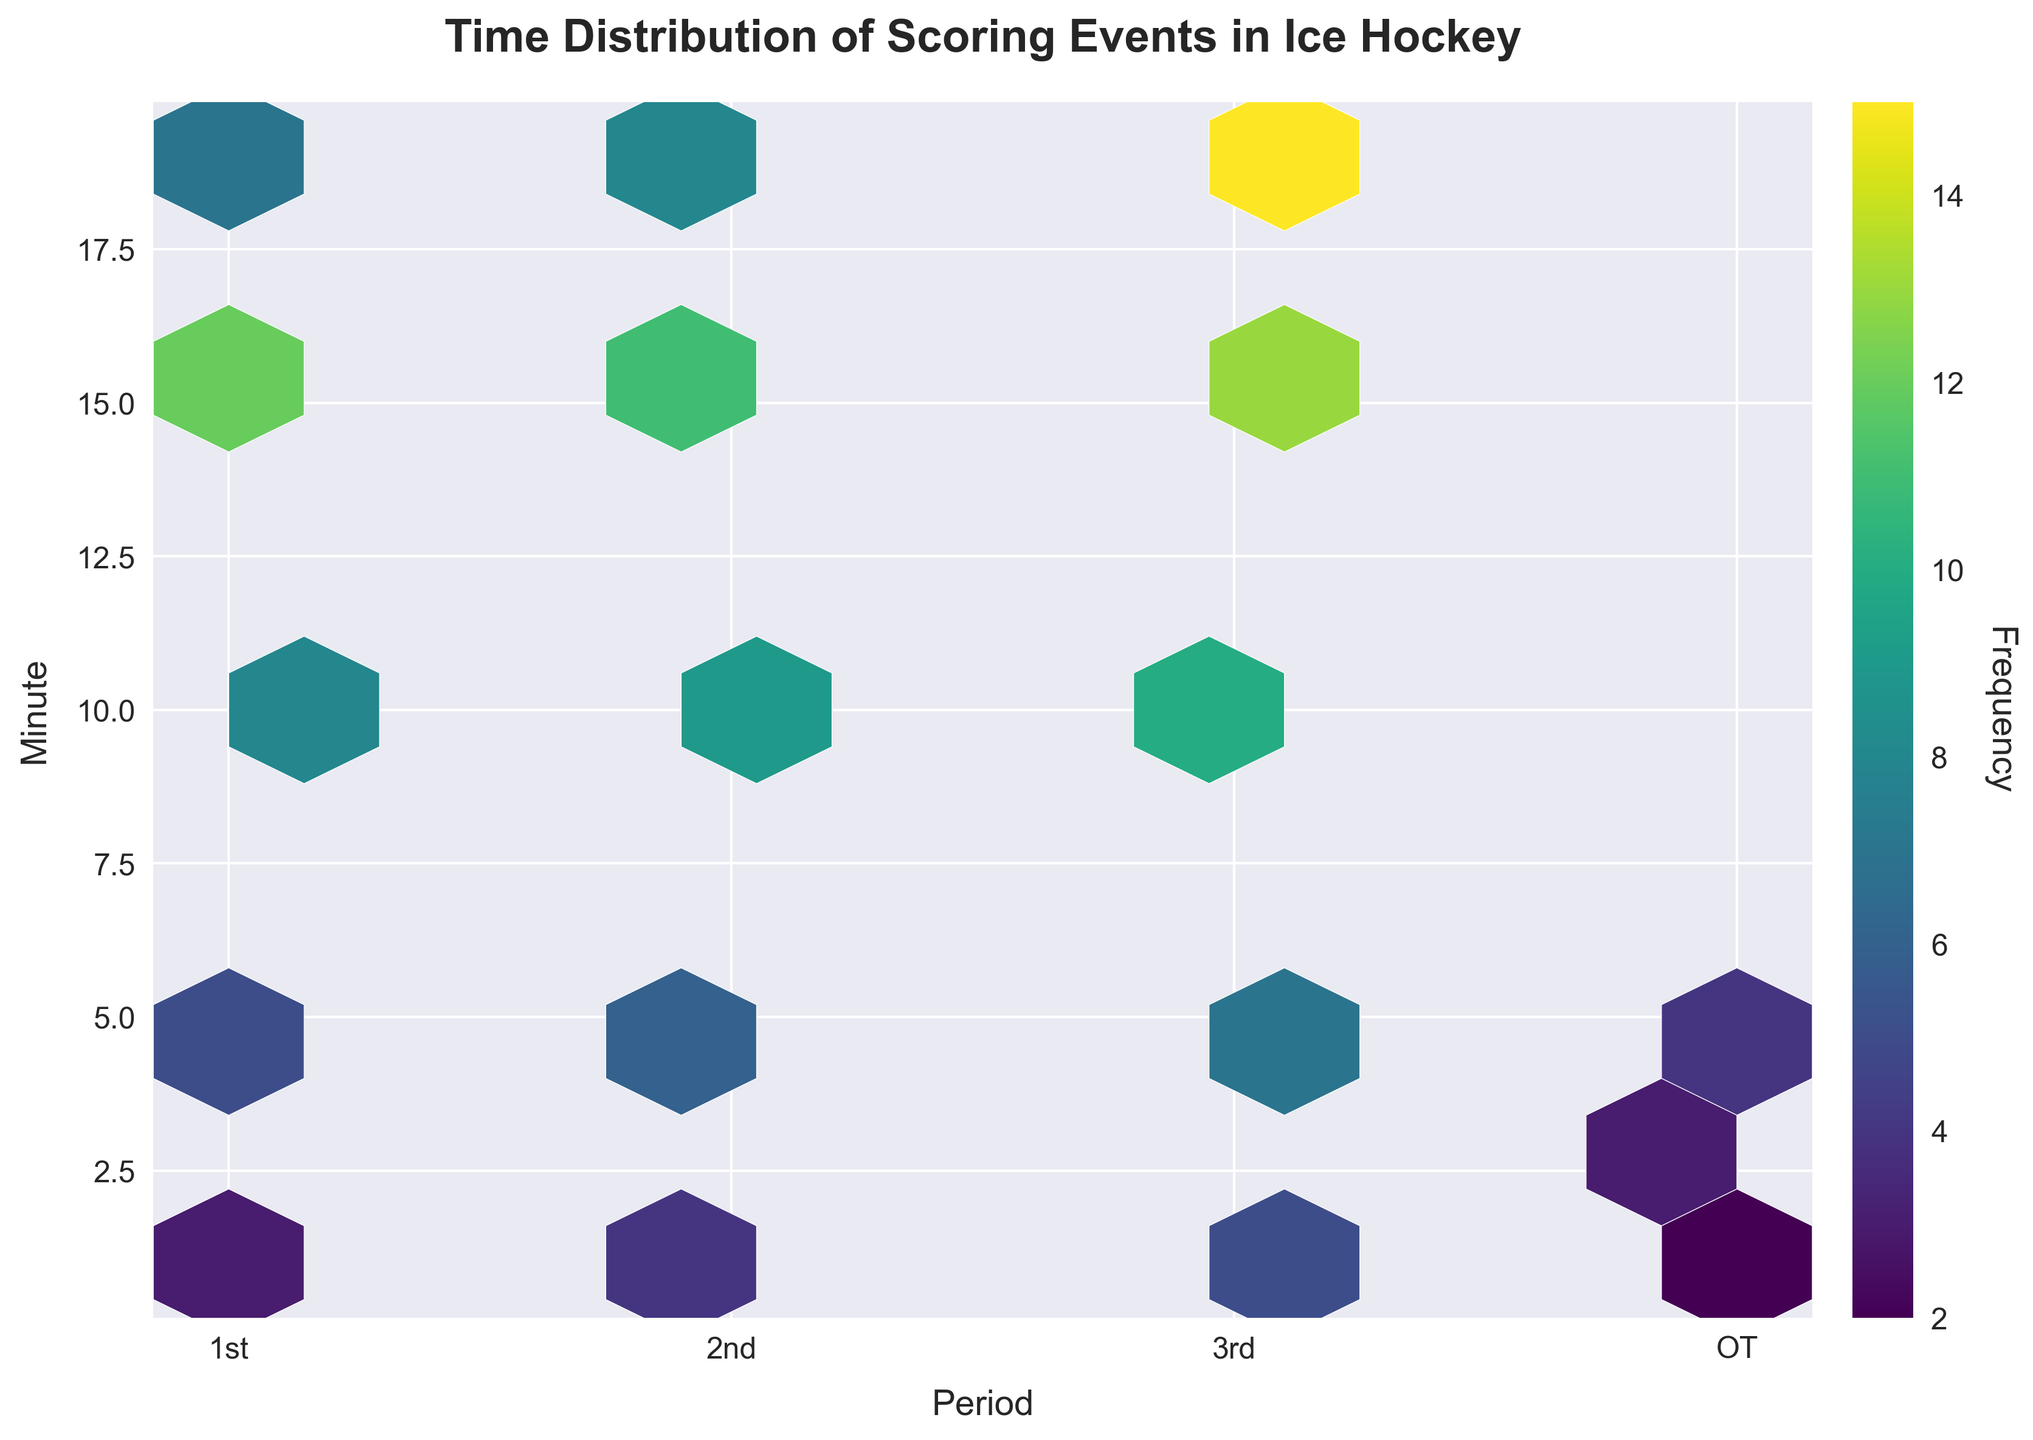How many periods are displayed in the plot? The x-axis shows four ticks labeled '1st', '2nd', '3rd', and 'OT', representing the periods.
Answer: 4 What colors indicate the highest frequency of scoring events? The colorbar ranges from lighter to darker shades; the darkest shade on the hexbin plot represents the highest frequency.
Answer: Dark green In which minute of the 3rd period do the most scoring events occur? Observe the hexbin density in the 3rd period on the x-axis; the highest frequency indicated by the darkest hexbin occurs at the 19th minute.
Answer: 19th Which period has the fewest minutes with high-frequency scoring events? Compare the density of bins across all periods; the OT period has fewer high-frequency bins than others.
Answer: OT What is the maximum frequency of scoring events that can be identified from the colorbar? The colorbar's label shows the range; the highest frequency value at the top is the maximum.
Answer: 15 Compare the frequency of scoring events in the 5th minute between the 1st and 2nd periods. Which has a higher frequency? Check the hexbin density for the 5th minute in both periods; the 1st period shows a lighter bin compared to the 2nd.
Answer: 2nd period What's the total frequency of scoring events in the 1st period? Add the frequencies from all minutes in the 1st period (3, 5, 8, 12, 7).
Answer: 35 Is there a minute where scoring events are evenly distributed across all periods? Look for a minute along the y-axis with equally dense bins across periods; no such minute appears consistently equal.
Answer: No What's the average frequency of scoring events in the OT period? Sum the frequencies in OT (2, 3, 4), then divide by the number of minutes (3). (2+3+4)/3 = 3.
Answer: 3 During which period is the 15th minute least frequently scored upon? Compare the hexbin density at the 15th minute across periods; the 1st period has the lightest bin.
Answer: 1st period 